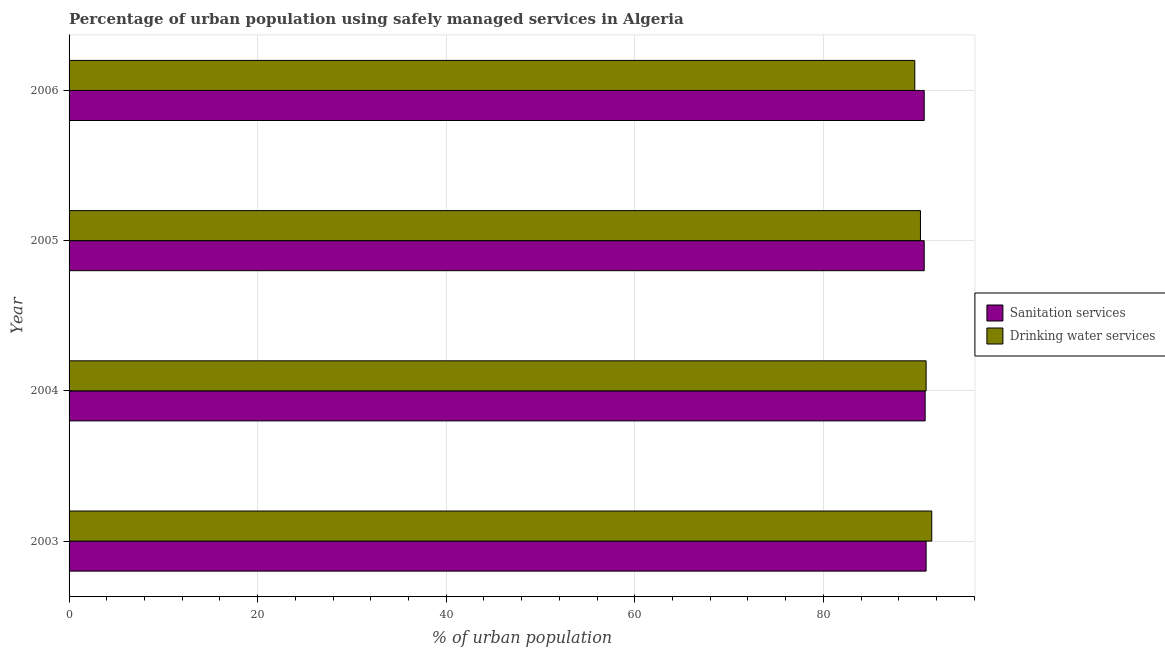Are the number of bars per tick equal to the number of legend labels?
Ensure brevity in your answer.  Yes. Are the number of bars on each tick of the Y-axis equal?
Keep it short and to the point. Yes. How many bars are there on the 1st tick from the bottom?
Your answer should be compact. 2. What is the label of the 4th group of bars from the top?
Your response must be concise. 2003. What is the percentage of urban population who used drinking water services in 2006?
Give a very brief answer. 89.7. Across all years, what is the maximum percentage of urban population who used sanitation services?
Provide a succinct answer. 90.9. Across all years, what is the minimum percentage of urban population who used drinking water services?
Your answer should be compact. 89.7. In which year was the percentage of urban population who used sanitation services maximum?
Provide a short and direct response. 2003. In which year was the percentage of urban population who used drinking water services minimum?
Keep it short and to the point. 2006. What is the total percentage of urban population who used drinking water services in the graph?
Your answer should be compact. 362.4. What is the difference between the percentage of urban population who used drinking water services in 2003 and the percentage of urban population who used sanitation services in 2006?
Keep it short and to the point. 0.8. What is the average percentage of urban population who used drinking water services per year?
Your answer should be compact. 90.6. In the year 2003, what is the difference between the percentage of urban population who used drinking water services and percentage of urban population who used sanitation services?
Keep it short and to the point. 0.6. What is the ratio of the percentage of urban population who used sanitation services in 2003 to that in 2005?
Offer a terse response. 1. Is the percentage of urban population who used sanitation services in 2004 less than that in 2006?
Provide a succinct answer. No. What is the difference between the highest and the second highest percentage of urban population who used sanitation services?
Your answer should be compact. 0.1. What is the difference between the highest and the lowest percentage of urban population who used drinking water services?
Make the answer very short. 1.8. In how many years, is the percentage of urban population who used drinking water services greater than the average percentage of urban population who used drinking water services taken over all years?
Offer a terse response. 2. Is the sum of the percentage of urban population who used drinking water services in 2003 and 2004 greater than the maximum percentage of urban population who used sanitation services across all years?
Make the answer very short. Yes. What does the 2nd bar from the top in 2003 represents?
Offer a terse response. Sanitation services. What does the 2nd bar from the bottom in 2006 represents?
Provide a succinct answer. Drinking water services. Are all the bars in the graph horizontal?
Offer a very short reply. Yes. How many years are there in the graph?
Your answer should be very brief. 4. Are the values on the major ticks of X-axis written in scientific E-notation?
Offer a very short reply. No. Where does the legend appear in the graph?
Provide a short and direct response. Center right. What is the title of the graph?
Give a very brief answer. Percentage of urban population using safely managed services in Algeria. What is the label or title of the X-axis?
Offer a terse response. % of urban population. What is the % of urban population of Sanitation services in 2003?
Keep it short and to the point. 90.9. What is the % of urban population in Drinking water services in 2003?
Provide a short and direct response. 91.5. What is the % of urban population in Sanitation services in 2004?
Offer a terse response. 90.8. What is the % of urban population in Drinking water services in 2004?
Provide a succinct answer. 90.9. What is the % of urban population in Sanitation services in 2005?
Keep it short and to the point. 90.7. What is the % of urban population in Drinking water services in 2005?
Keep it short and to the point. 90.3. What is the % of urban population of Sanitation services in 2006?
Your answer should be compact. 90.7. What is the % of urban population of Drinking water services in 2006?
Offer a very short reply. 89.7. Across all years, what is the maximum % of urban population in Sanitation services?
Offer a terse response. 90.9. Across all years, what is the maximum % of urban population of Drinking water services?
Offer a very short reply. 91.5. Across all years, what is the minimum % of urban population in Sanitation services?
Your answer should be compact. 90.7. Across all years, what is the minimum % of urban population of Drinking water services?
Offer a very short reply. 89.7. What is the total % of urban population of Sanitation services in the graph?
Give a very brief answer. 363.1. What is the total % of urban population of Drinking water services in the graph?
Ensure brevity in your answer.  362.4. What is the difference between the % of urban population in Sanitation services in 2003 and that in 2004?
Your response must be concise. 0.1. What is the difference between the % of urban population in Drinking water services in 2003 and that in 2004?
Make the answer very short. 0.6. What is the difference between the % of urban population in Sanitation services in 2003 and that in 2005?
Your answer should be compact. 0.2. What is the difference between the % of urban population of Sanitation services in 2004 and that in 2006?
Your answer should be compact. 0.1. What is the difference between the % of urban population in Drinking water services in 2004 and that in 2006?
Give a very brief answer. 1.2. What is the difference between the % of urban population of Sanitation services in 2004 and the % of urban population of Drinking water services in 2005?
Offer a very short reply. 0.5. What is the difference between the % of urban population in Sanitation services in 2005 and the % of urban population in Drinking water services in 2006?
Keep it short and to the point. 1. What is the average % of urban population in Sanitation services per year?
Your answer should be compact. 90.78. What is the average % of urban population of Drinking water services per year?
Offer a very short reply. 90.6. In the year 2006, what is the difference between the % of urban population in Sanitation services and % of urban population in Drinking water services?
Your answer should be very brief. 1. What is the ratio of the % of urban population in Drinking water services in 2003 to that in 2004?
Your answer should be compact. 1.01. What is the ratio of the % of urban population in Sanitation services in 2003 to that in 2005?
Your answer should be very brief. 1. What is the ratio of the % of urban population in Drinking water services in 2003 to that in 2005?
Offer a terse response. 1.01. What is the ratio of the % of urban population in Sanitation services in 2003 to that in 2006?
Provide a short and direct response. 1. What is the ratio of the % of urban population in Drinking water services in 2003 to that in 2006?
Offer a terse response. 1.02. What is the ratio of the % of urban population in Drinking water services in 2004 to that in 2005?
Your response must be concise. 1.01. What is the ratio of the % of urban population of Sanitation services in 2004 to that in 2006?
Keep it short and to the point. 1. What is the ratio of the % of urban population in Drinking water services in 2004 to that in 2006?
Provide a succinct answer. 1.01. What is the ratio of the % of urban population of Sanitation services in 2005 to that in 2006?
Offer a terse response. 1. What is the difference between the highest and the second highest % of urban population in Sanitation services?
Make the answer very short. 0.1. What is the difference between the highest and the second highest % of urban population in Drinking water services?
Offer a very short reply. 0.6. What is the difference between the highest and the lowest % of urban population of Sanitation services?
Make the answer very short. 0.2. What is the difference between the highest and the lowest % of urban population of Drinking water services?
Provide a succinct answer. 1.8. 